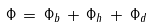<formula> <loc_0><loc_0><loc_500><loc_500>\Phi \, = \, \Phi _ { b } \, + \, \Phi _ { h } \, + \, \Phi _ { d }</formula> 